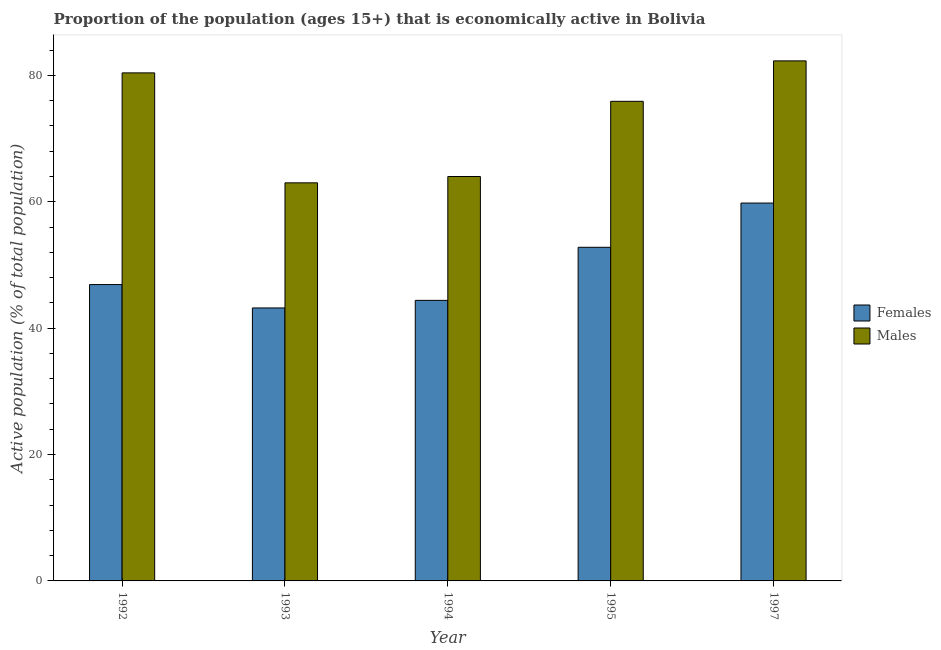Are the number of bars on each tick of the X-axis equal?
Make the answer very short. Yes. What is the percentage of economically active female population in 1992?
Offer a very short reply. 46.9. Across all years, what is the maximum percentage of economically active female population?
Offer a terse response. 59.8. Across all years, what is the minimum percentage of economically active male population?
Your response must be concise. 63. In which year was the percentage of economically active female population maximum?
Give a very brief answer. 1997. In which year was the percentage of economically active female population minimum?
Keep it short and to the point. 1993. What is the total percentage of economically active female population in the graph?
Offer a very short reply. 247.1. What is the difference between the percentage of economically active female population in 1994 and the percentage of economically active male population in 1997?
Offer a terse response. -15.4. What is the average percentage of economically active male population per year?
Give a very brief answer. 73.12. In how many years, is the percentage of economically active male population greater than 44 %?
Make the answer very short. 5. What is the ratio of the percentage of economically active male population in 1992 to that in 1994?
Provide a short and direct response. 1.26. Is the percentage of economically active male population in 1992 less than that in 1997?
Make the answer very short. Yes. What is the difference between the highest and the second highest percentage of economically active male population?
Your answer should be compact. 1.9. What is the difference between the highest and the lowest percentage of economically active male population?
Provide a short and direct response. 19.3. What does the 1st bar from the left in 1997 represents?
Provide a succinct answer. Females. What does the 2nd bar from the right in 1992 represents?
Make the answer very short. Females. How many bars are there?
Provide a short and direct response. 10. Are all the bars in the graph horizontal?
Keep it short and to the point. No. How many years are there in the graph?
Offer a very short reply. 5. Are the values on the major ticks of Y-axis written in scientific E-notation?
Ensure brevity in your answer.  No. Does the graph contain grids?
Provide a succinct answer. No. Where does the legend appear in the graph?
Keep it short and to the point. Center right. What is the title of the graph?
Make the answer very short. Proportion of the population (ages 15+) that is economically active in Bolivia. What is the label or title of the Y-axis?
Provide a short and direct response. Active population (% of total population). What is the Active population (% of total population) of Females in 1992?
Offer a very short reply. 46.9. What is the Active population (% of total population) of Males in 1992?
Ensure brevity in your answer.  80.4. What is the Active population (% of total population) of Females in 1993?
Provide a short and direct response. 43.2. What is the Active population (% of total population) in Males in 1993?
Your answer should be very brief. 63. What is the Active population (% of total population) of Females in 1994?
Provide a succinct answer. 44.4. What is the Active population (% of total population) in Males in 1994?
Your response must be concise. 64. What is the Active population (% of total population) of Females in 1995?
Give a very brief answer. 52.8. What is the Active population (% of total population) of Males in 1995?
Offer a very short reply. 75.9. What is the Active population (% of total population) in Females in 1997?
Provide a succinct answer. 59.8. What is the Active population (% of total population) in Males in 1997?
Give a very brief answer. 82.3. Across all years, what is the maximum Active population (% of total population) in Females?
Offer a very short reply. 59.8. Across all years, what is the maximum Active population (% of total population) of Males?
Your answer should be very brief. 82.3. Across all years, what is the minimum Active population (% of total population) in Females?
Provide a succinct answer. 43.2. What is the total Active population (% of total population) of Females in the graph?
Offer a very short reply. 247.1. What is the total Active population (% of total population) in Males in the graph?
Offer a very short reply. 365.6. What is the difference between the Active population (% of total population) of Males in 1992 and that in 1993?
Keep it short and to the point. 17.4. What is the difference between the Active population (% of total population) of Females in 1992 and that in 1994?
Make the answer very short. 2.5. What is the difference between the Active population (% of total population) of Males in 1992 and that in 1994?
Keep it short and to the point. 16.4. What is the difference between the Active population (% of total population) in Males in 1992 and that in 1997?
Give a very brief answer. -1.9. What is the difference between the Active population (% of total population) of Females in 1993 and that in 1995?
Your answer should be very brief. -9.6. What is the difference between the Active population (% of total population) of Males in 1993 and that in 1995?
Your answer should be compact. -12.9. What is the difference between the Active population (% of total population) in Females in 1993 and that in 1997?
Offer a terse response. -16.6. What is the difference between the Active population (% of total population) of Males in 1993 and that in 1997?
Give a very brief answer. -19.3. What is the difference between the Active population (% of total population) in Females in 1994 and that in 1997?
Offer a terse response. -15.4. What is the difference between the Active population (% of total population) of Males in 1994 and that in 1997?
Ensure brevity in your answer.  -18.3. What is the difference between the Active population (% of total population) in Females in 1995 and that in 1997?
Your answer should be compact. -7. What is the difference between the Active population (% of total population) of Males in 1995 and that in 1997?
Give a very brief answer. -6.4. What is the difference between the Active population (% of total population) in Females in 1992 and the Active population (% of total population) in Males in 1993?
Your response must be concise. -16.1. What is the difference between the Active population (% of total population) of Females in 1992 and the Active population (% of total population) of Males in 1994?
Your answer should be very brief. -17.1. What is the difference between the Active population (% of total population) of Females in 1992 and the Active population (% of total population) of Males in 1995?
Provide a succinct answer. -29. What is the difference between the Active population (% of total population) of Females in 1992 and the Active population (% of total population) of Males in 1997?
Provide a short and direct response. -35.4. What is the difference between the Active population (% of total population) in Females in 1993 and the Active population (% of total population) in Males in 1994?
Offer a very short reply. -20.8. What is the difference between the Active population (% of total population) in Females in 1993 and the Active population (% of total population) in Males in 1995?
Offer a terse response. -32.7. What is the difference between the Active population (% of total population) in Females in 1993 and the Active population (% of total population) in Males in 1997?
Provide a succinct answer. -39.1. What is the difference between the Active population (% of total population) of Females in 1994 and the Active population (% of total population) of Males in 1995?
Ensure brevity in your answer.  -31.5. What is the difference between the Active population (% of total population) in Females in 1994 and the Active population (% of total population) in Males in 1997?
Ensure brevity in your answer.  -37.9. What is the difference between the Active population (% of total population) in Females in 1995 and the Active population (% of total population) in Males in 1997?
Provide a short and direct response. -29.5. What is the average Active population (% of total population) in Females per year?
Offer a terse response. 49.42. What is the average Active population (% of total population) in Males per year?
Ensure brevity in your answer.  73.12. In the year 1992, what is the difference between the Active population (% of total population) in Females and Active population (% of total population) in Males?
Your response must be concise. -33.5. In the year 1993, what is the difference between the Active population (% of total population) in Females and Active population (% of total population) in Males?
Your response must be concise. -19.8. In the year 1994, what is the difference between the Active population (% of total population) of Females and Active population (% of total population) of Males?
Your response must be concise. -19.6. In the year 1995, what is the difference between the Active population (% of total population) of Females and Active population (% of total population) of Males?
Give a very brief answer. -23.1. In the year 1997, what is the difference between the Active population (% of total population) of Females and Active population (% of total population) of Males?
Give a very brief answer. -22.5. What is the ratio of the Active population (% of total population) of Females in 1992 to that in 1993?
Ensure brevity in your answer.  1.09. What is the ratio of the Active population (% of total population) of Males in 1992 to that in 1993?
Your response must be concise. 1.28. What is the ratio of the Active population (% of total population) in Females in 1992 to that in 1994?
Keep it short and to the point. 1.06. What is the ratio of the Active population (% of total population) in Males in 1992 to that in 1994?
Your answer should be compact. 1.26. What is the ratio of the Active population (% of total population) of Females in 1992 to that in 1995?
Your response must be concise. 0.89. What is the ratio of the Active population (% of total population) in Males in 1992 to that in 1995?
Give a very brief answer. 1.06. What is the ratio of the Active population (% of total population) of Females in 1992 to that in 1997?
Your answer should be very brief. 0.78. What is the ratio of the Active population (% of total population) of Males in 1992 to that in 1997?
Keep it short and to the point. 0.98. What is the ratio of the Active population (% of total population) in Males in 1993 to that in 1994?
Provide a succinct answer. 0.98. What is the ratio of the Active population (% of total population) in Females in 1993 to that in 1995?
Offer a very short reply. 0.82. What is the ratio of the Active population (% of total population) of Males in 1993 to that in 1995?
Your response must be concise. 0.83. What is the ratio of the Active population (% of total population) of Females in 1993 to that in 1997?
Ensure brevity in your answer.  0.72. What is the ratio of the Active population (% of total population) in Males in 1993 to that in 1997?
Your answer should be compact. 0.77. What is the ratio of the Active population (% of total population) of Females in 1994 to that in 1995?
Your response must be concise. 0.84. What is the ratio of the Active population (% of total population) in Males in 1994 to that in 1995?
Keep it short and to the point. 0.84. What is the ratio of the Active population (% of total population) in Females in 1994 to that in 1997?
Ensure brevity in your answer.  0.74. What is the ratio of the Active population (% of total population) of Males in 1994 to that in 1997?
Make the answer very short. 0.78. What is the ratio of the Active population (% of total population) in Females in 1995 to that in 1997?
Your answer should be compact. 0.88. What is the ratio of the Active population (% of total population) in Males in 1995 to that in 1997?
Offer a terse response. 0.92. What is the difference between the highest and the second highest Active population (% of total population) of Females?
Provide a succinct answer. 7. What is the difference between the highest and the lowest Active population (% of total population) in Males?
Your response must be concise. 19.3. 